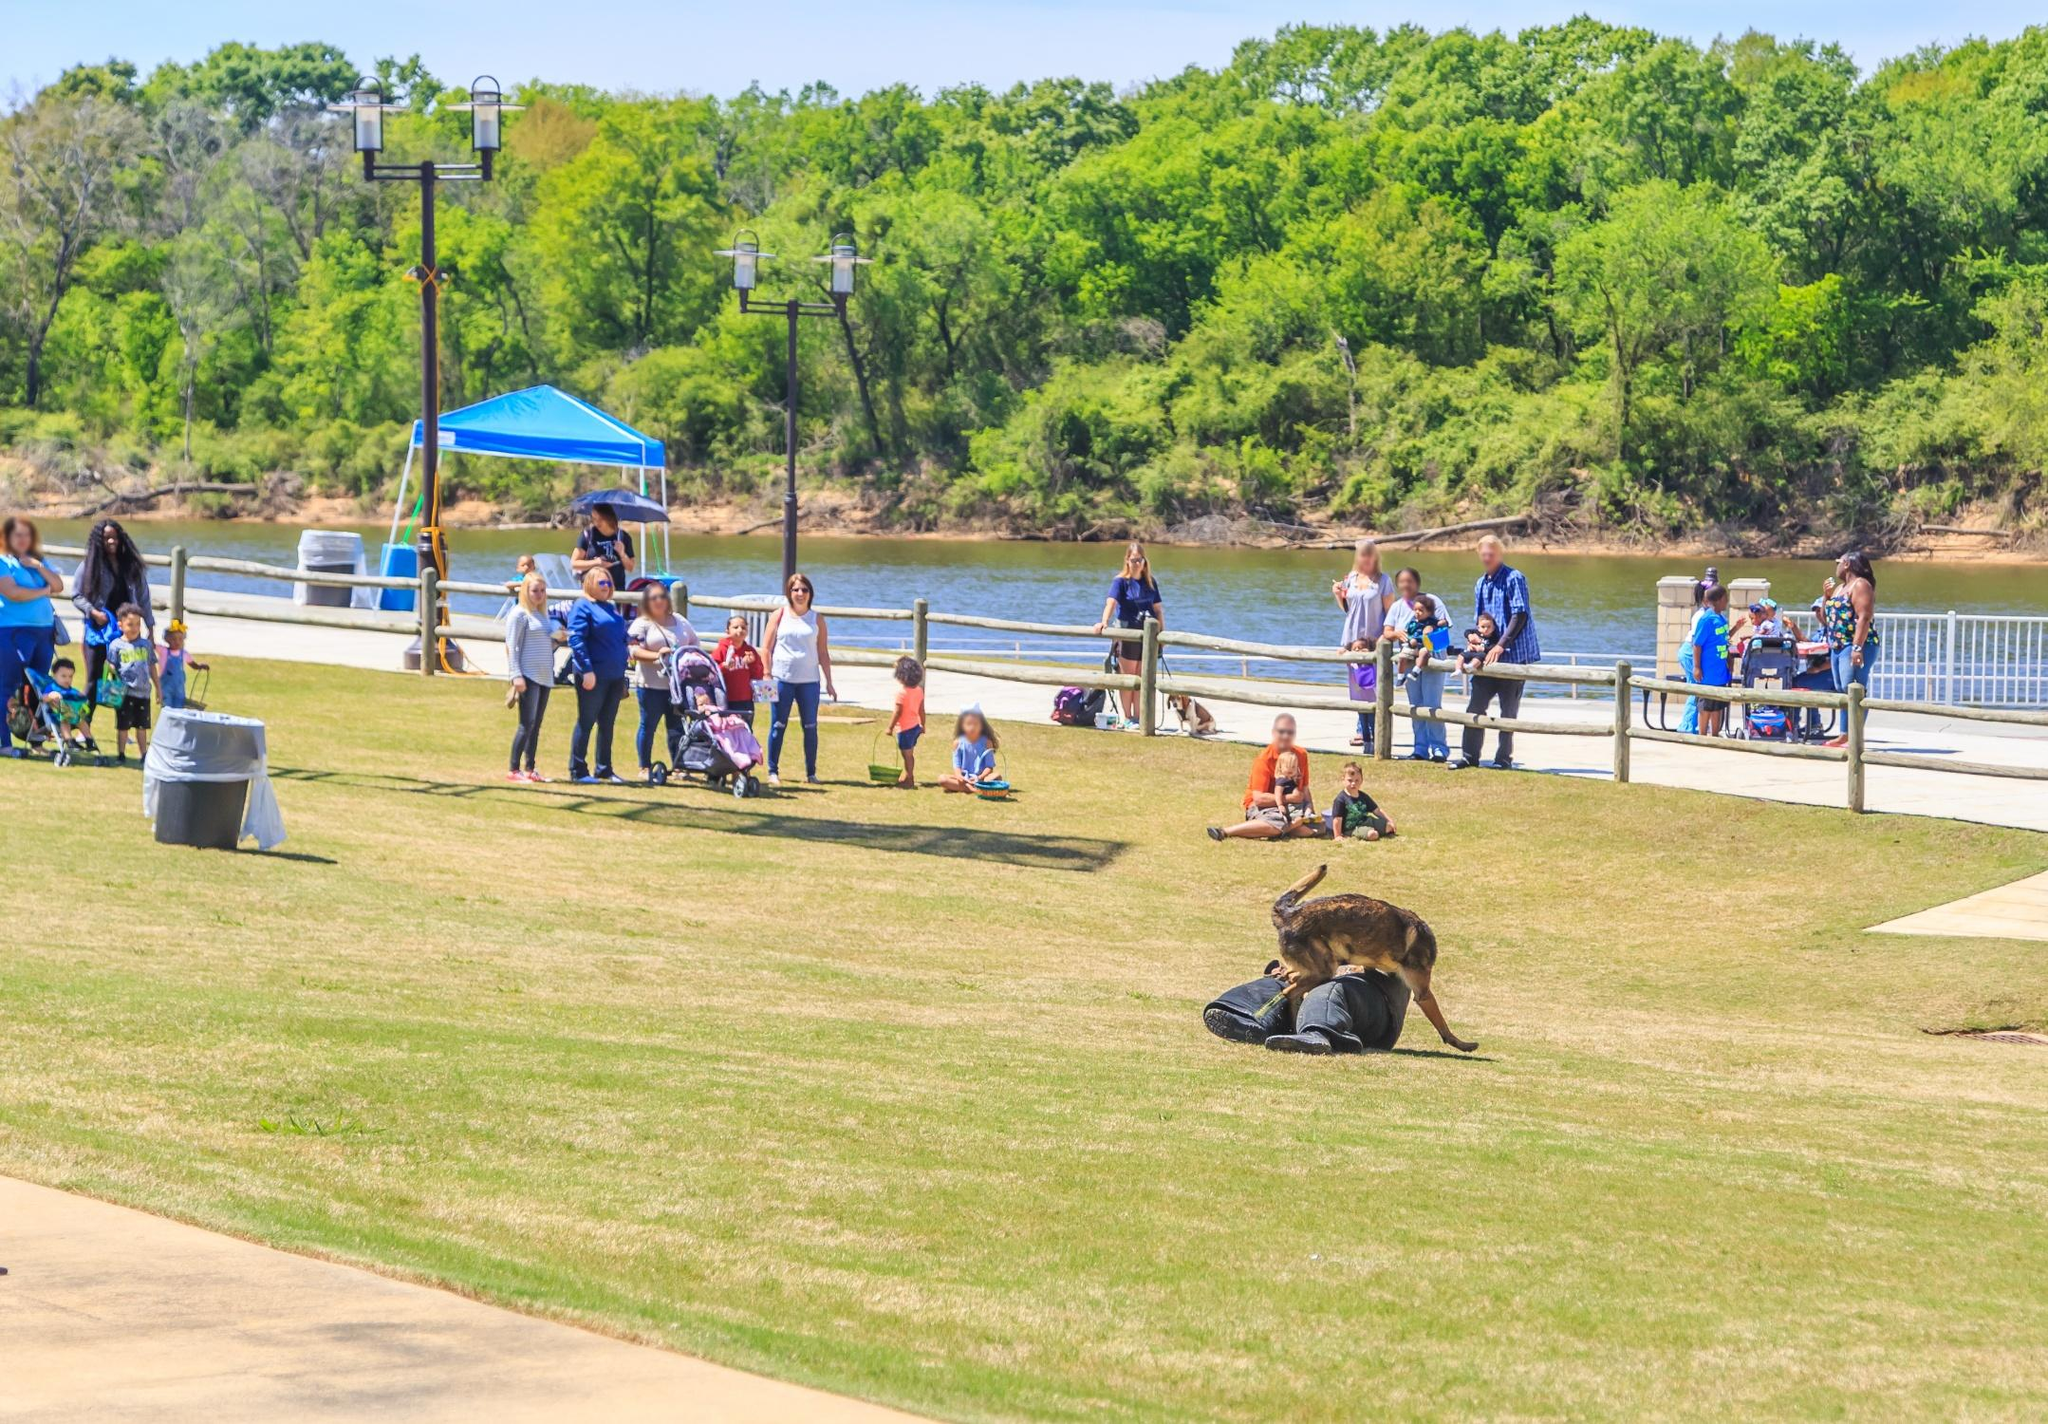Describe a possible scenario where the park holds a community event. Imagine the park being transformed into a hub of excitement for a community event. Various stalls are set up along the walkway, offering food, handmade crafts, and local produce. Children’s laughter fills the air as they participate in organized games and activities. A stage near the river hosts live performances by local musicians, drawing applause from an enthusiastic crowd. Families are picnicking on the grass, while others engage in friendly sports competitions. The ambiance is lively and festive, with neighbors mingling and enjoying the sense of community. 